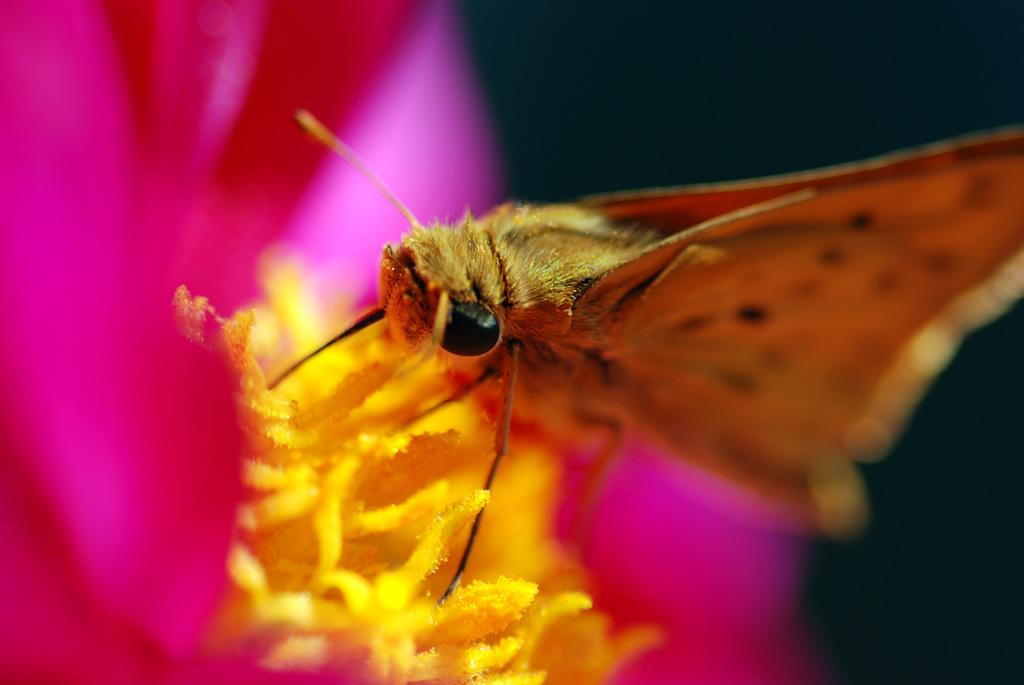What is the main subject of the image? The main subject of the image is a butterfly. Where is the butterfly located in the image? The butterfly is in the center of the image. What is the butterfly resting on in the image? The butterfly is on a flower. How does the stem of the flower look like in the image? There is no mention of a stem in the provided facts, so it cannot be determined from the image. What is the butterfly's wish while resting on the flower in the image? Butterflies do not have the ability to make wishes, so this question cannot be answered definitively from the image. 